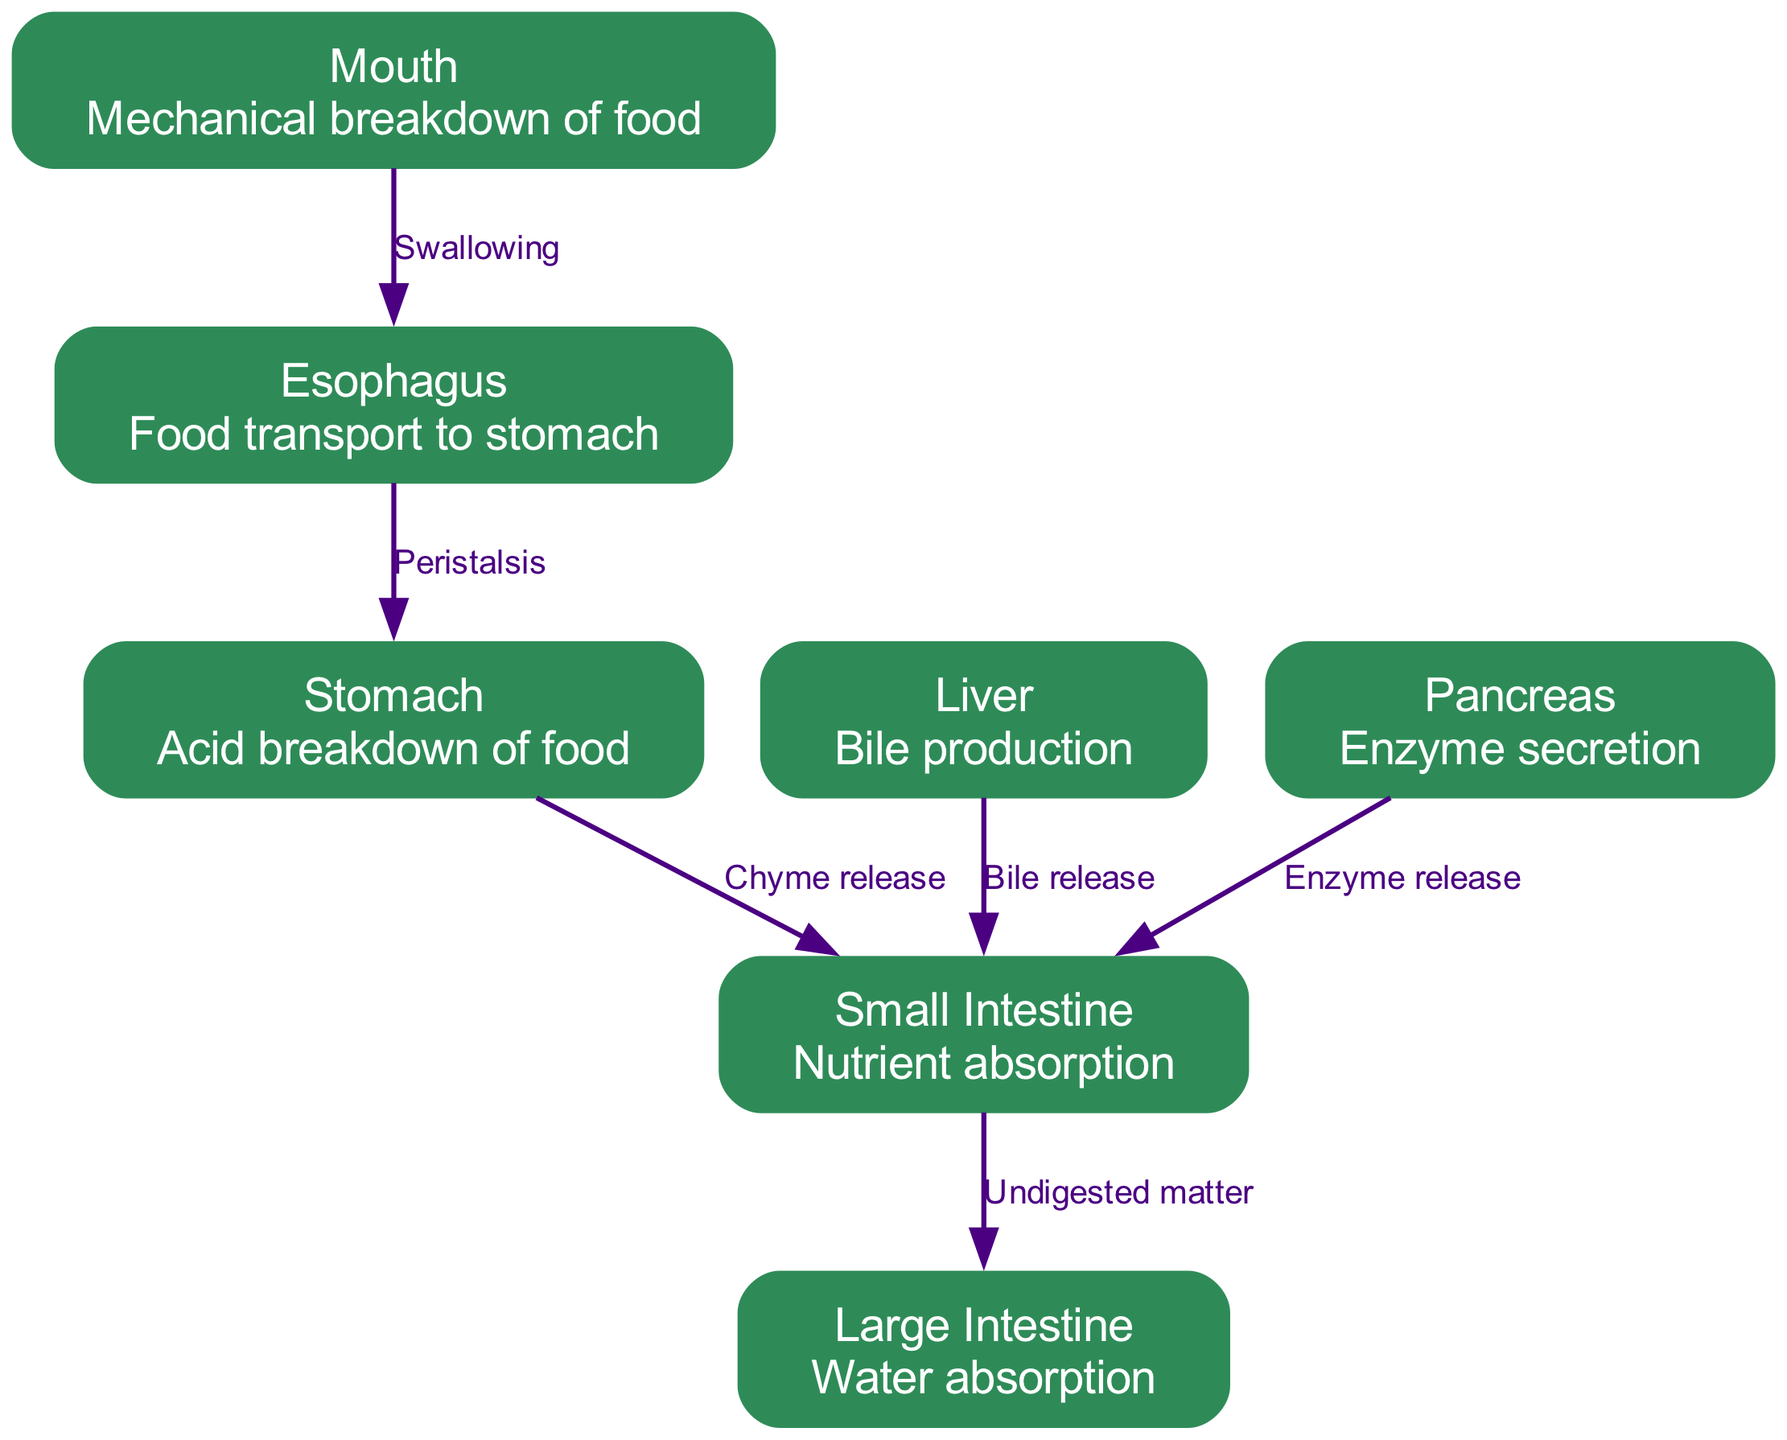What is the function of the stomach? The diagram states that the stomach is responsible for the "Acid breakdown of food." This is a direct reference from the node description of the stomach.
Answer: Acid breakdown of food How many organs are shown in the diagram? By counting the nodes, we see there are seven labeled organs: Mouth, Esophagus, Stomach, Small Intestine, Large Intestine, Liver, and Pancreas. Thus, the total number of organs is seven.
Answer: Seven What transports food from the mouth to the stomach? The edge labeled "Swallowing" connects the mouth node to the esophagus node, indicating that the process of swallowing is what transports food from the mouth to the stomach.
Answer: Swallowing Which organ is responsible for bile production? The liver node description specifies "Bile production," making it the organ responsible for this process.
Answer: Liver What does the pancreas secrete into the small intestine? According to the edge connecting the pancreas to the small intestine, the pancreas releases "Enzyme," which is the substance secreted.
Answer: Enzyme What connects the stomach to the small intestine? The diagram shows an edge labeled "Chyme release" from the stomach node to the small intestine node, indicating that this process connects the two organs.
Answer: Chyme release What is the primary role of the large intestine? The node description for the large intestine states it's responsible for "Water absorption," which is its primary role in digestion.
Answer: Water absorption How many processes are listed in the diagram? By reviewing the edges in the diagram, we see there are six labeled processes that connect the organs, thus indicating that the total number of processes present is six.
Answer: Six What releases bile into the small intestine? The diagram shows an edge from the liver to the small intestine labeled "Bile release," which designates the liver as the organ that releases bile into the small intestine.
Answer: Bile release 